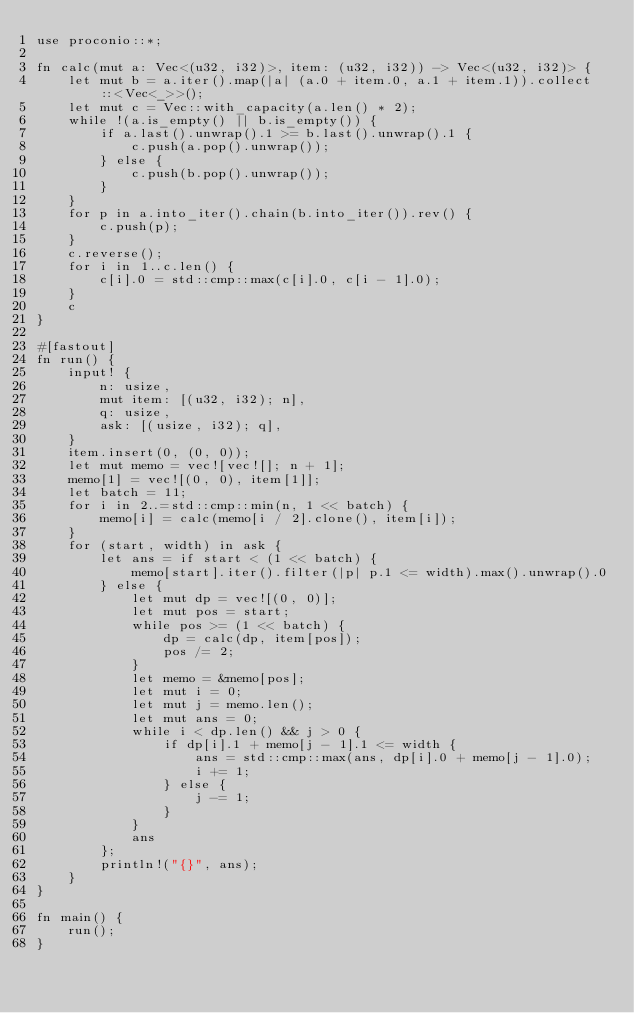Convert code to text. <code><loc_0><loc_0><loc_500><loc_500><_Rust_>use proconio::*;

fn calc(mut a: Vec<(u32, i32)>, item: (u32, i32)) -> Vec<(u32, i32)> {
    let mut b = a.iter().map(|a| (a.0 + item.0, a.1 + item.1)).collect::<Vec<_>>();
    let mut c = Vec::with_capacity(a.len() * 2);
    while !(a.is_empty() || b.is_empty()) {
        if a.last().unwrap().1 >= b.last().unwrap().1 {
            c.push(a.pop().unwrap());
        } else {
            c.push(b.pop().unwrap());
        }
    }
    for p in a.into_iter().chain(b.into_iter()).rev() {
        c.push(p);
    }
    c.reverse();
    for i in 1..c.len() {
        c[i].0 = std::cmp::max(c[i].0, c[i - 1].0);
    }
    c
}

#[fastout]
fn run() {
    input! {
        n: usize,
        mut item: [(u32, i32); n],
        q: usize,
        ask: [(usize, i32); q],
    }
    item.insert(0, (0, 0));
    let mut memo = vec![vec![]; n + 1];
    memo[1] = vec![(0, 0), item[1]];
    let batch = 11;
    for i in 2..=std::cmp::min(n, 1 << batch) {
        memo[i] = calc(memo[i / 2].clone(), item[i]);
    }
    for (start, width) in ask {
        let ans = if start < (1 << batch) {
            memo[start].iter().filter(|p| p.1 <= width).max().unwrap().0
        } else {
            let mut dp = vec![(0, 0)];
            let mut pos = start;
            while pos >= (1 << batch) {
                dp = calc(dp, item[pos]);
                pos /= 2;
            }
            let memo = &memo[pos];
            let mut i = 0;
            let mut j = memo.len();
            let mut ans = 0;
            while i < dp.len() && j > 0 {
                if dp[i].1 + memo[j - 1].1 <= width {
                    ans = std::cmp::max(ans, dp[i].0 + memo[j - 1].0);
                    i += 1;
                } else {
                    j -= 1;
                }
            }
            ans
        };
        println!("{}", ans);
    }
}

fn main() {
    run();
}
</code> 